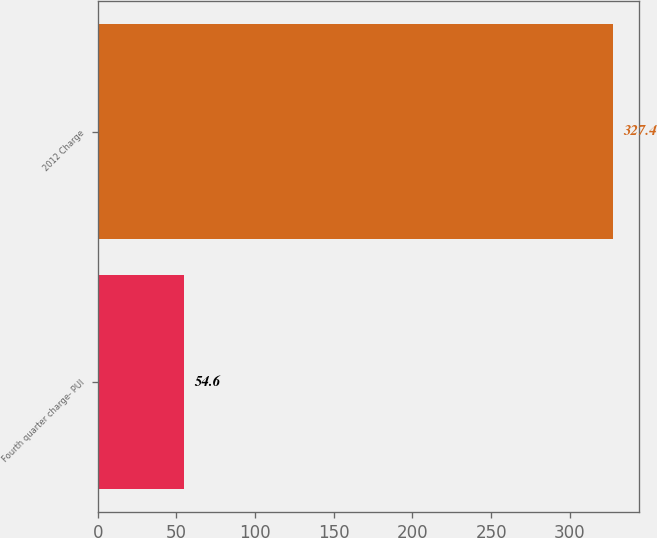<chart> <loc_0><loc_0><loc_500><loc_500><bar_chart><fcel>Fourth quarter charge- PUI<fcel>2012 Charge<nl><fcel>54.6<fcel>327.4<nl></chart> 